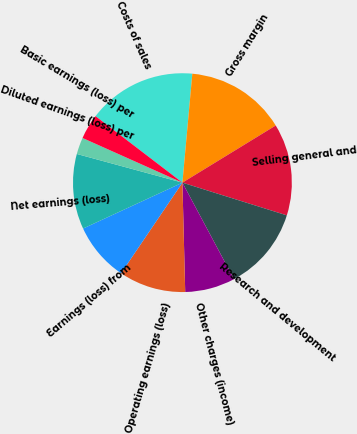<chart> <loc_0><loc_0><loc_500><loc_500><pie_chart><fcel>Costs of sales<fcel>Gross margin<fcel>Selling general and<fcel>Research and development<fcel>Other charges (income)<fcel>Operating earnings (loss)<fcel>Earnings (loss) from<fcel>Net earnings (loss)<fcel>Diluted earnings (loss) per<fcel>Basic earnings (loss) per<nl><fcel>16.05%<fcel>14.81%<fcel>13.58%<fcel>12.35%<fcel>7.41%<fcel>9.88%<fcel>8.64%<fcel>11.11%<fcel>2.47%<fcel>3.7%<nl></chart> 